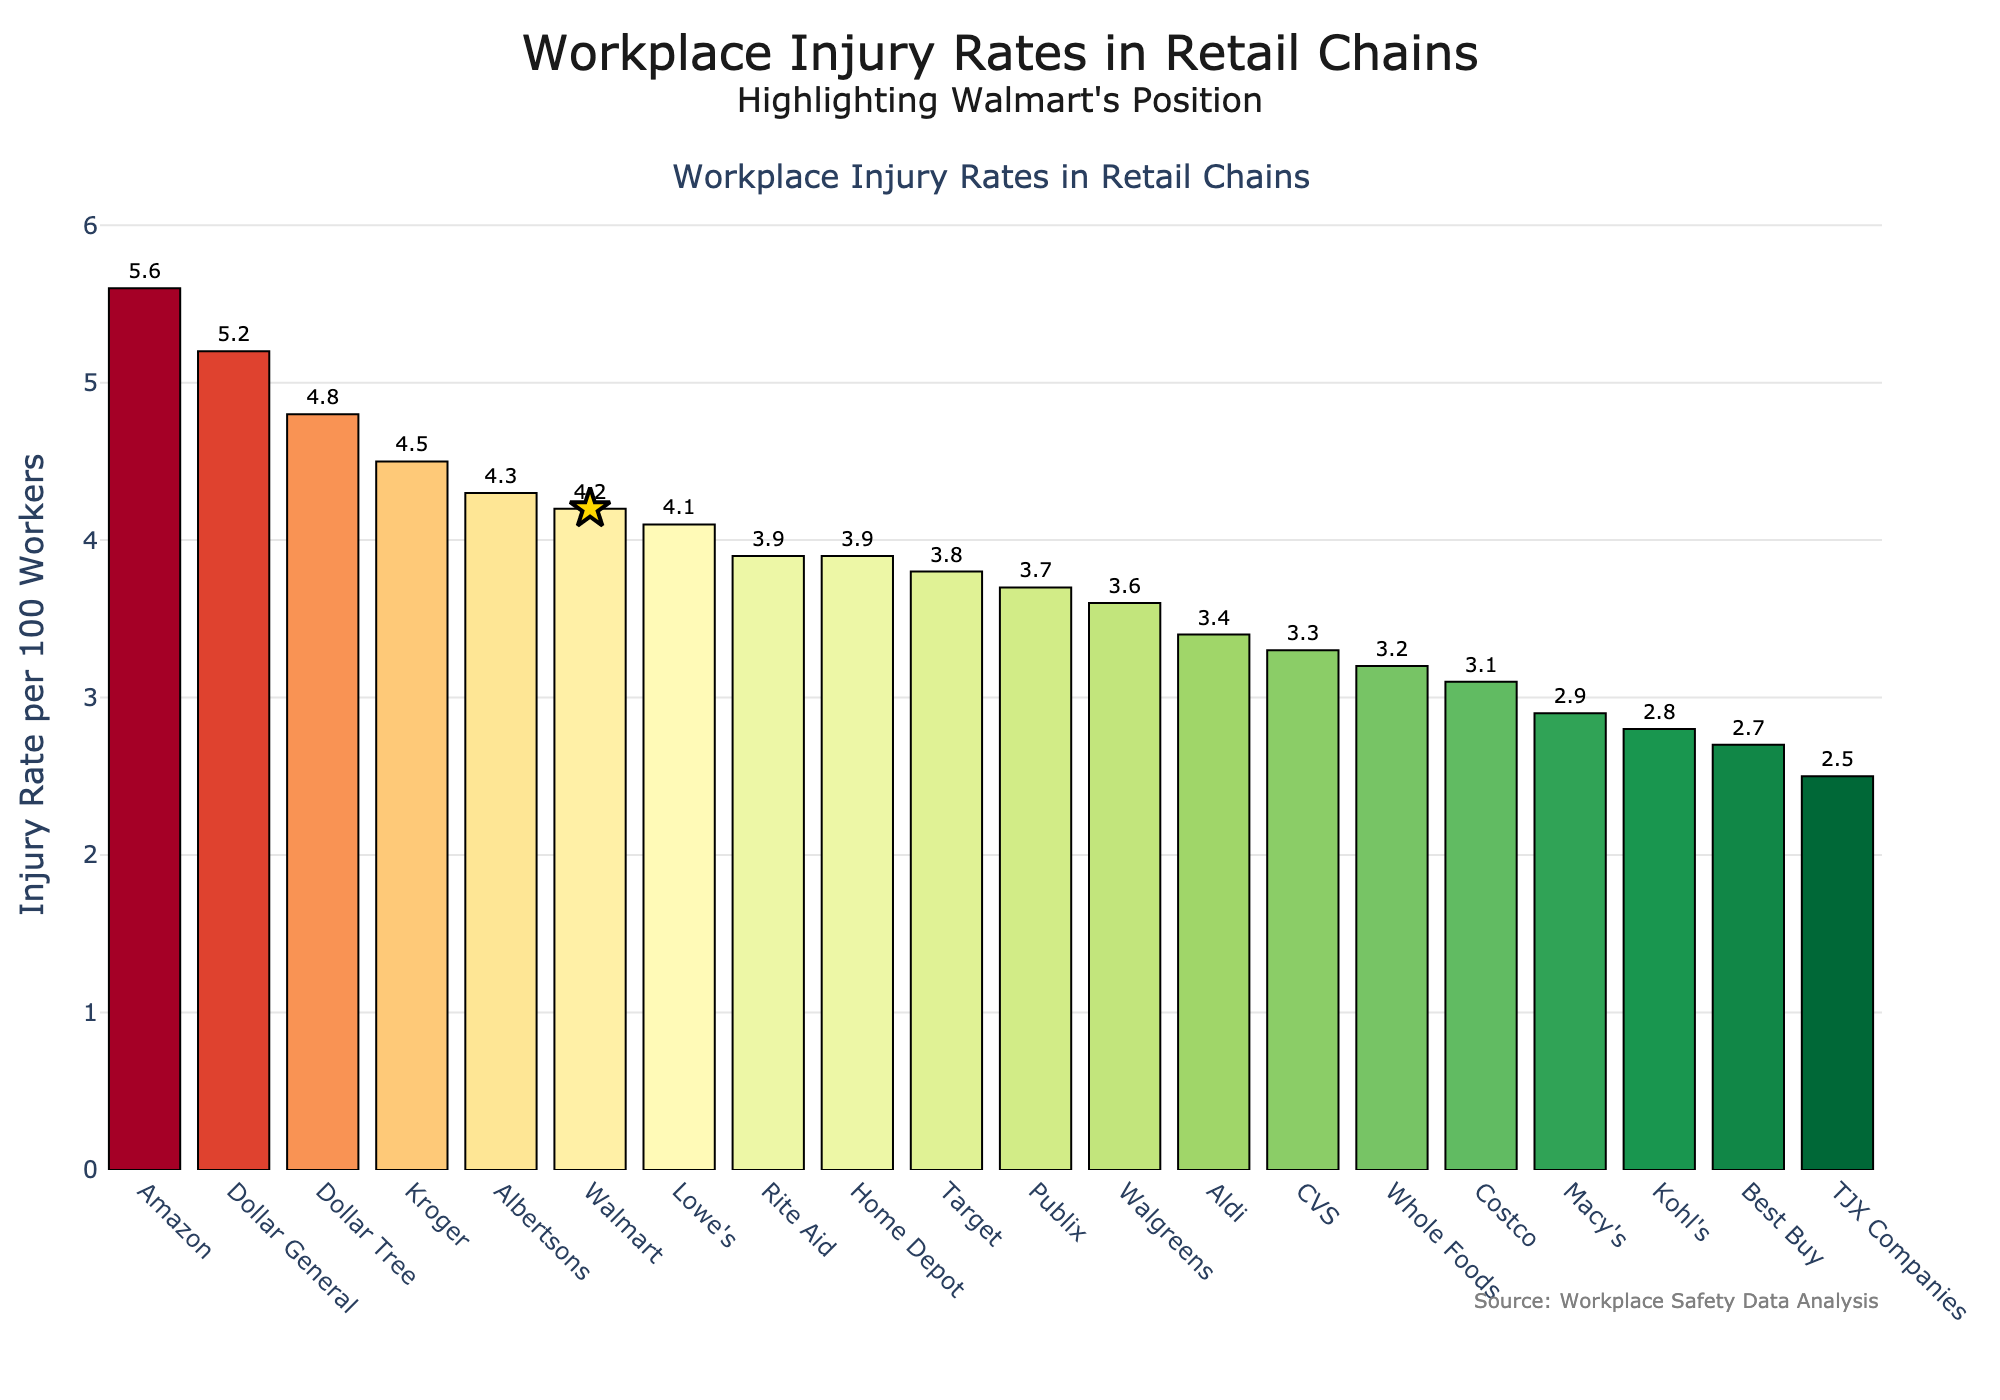Which company has the highest workplace injury rate? Observing the figure, the bar representing Amazon is the tallest, indicating that it has the highest injury rate among the companies listed.
Answer: Amazon What is Walmart's injury rate, and how does it compare to the average injury rate of all companies? Walmart's injury rate is 4.2. To find the average, we sum all injury rates and divide by the number of companies: (4.2 + 3.8 + 3.1 + 5.6 + 3.9 + 4.1 + 2.7 + 4.5 + 3.3 + 3.6 + 2.9 + 5.2 + 4.8 + 3.7 + 4.3 + 2.5 + 3.4 + 2.8 + 3.2 + 3.9) / 20 = 3.785. Walmart's rate is higher than the average.
Answer: 4.2, higher Which company has a workplace injury rate closest to Walmart but still lower? Observing the bars closely, Lowe's has a rate of 4.1, which is slightly lower than Walmart's rate of 4.2.
Answer: Lowe's Rank the top three companies with the highest injury rates. By examining the heights of the bars, the three tallest bars correspond to Amazon (5.6), Dollar General (5.2), and Dollar Tree (4.8).
Answer: Amazon, Dollar General, Dollar Tree Which company has the lowest workplace injury rate, and what is its rate? The shortest bar represents TJX Companies, which has the lowest workplace injury rate. The height of this bar indicates a rate of 2.5.
Answer: TJX Companies, 2.5 How much greater is Amazon's injury rate compared to Walmart's? Amazon's injury rate is 5.6, and Walmart's is 4.2. Subtracting the two gives 5.6 - 4.2 = 1.4. Thus, Amazon's rate is 1.4 higher than Walmart's.
Answer: 1.4 Which companies have injury rates above 4.0? By observing the bars above 4.0, we identify Amazon, Dollar General, Dollar Tree, Kroger, Albertsons, and Walmart.
Answer: Amazon, Dollar General, Dollar Tree, Kroger, Albertsons, Walmart Compare the injury rates of the highest and lowest companies. What is the difference? The highest rate is Amazon's at 5.6, and the lowest is TJX Companies at 2.5. Subtracting the two gives 5.6 - 2.5 = 3.1. The difference between the highest and lowest injury rates is 3.1.
Answer: 3.1 Can you identify the companies with injury rates between 3.0 and 4.0? By examining the bars that fall within the 3.0 to 4.0 range, the companies are Target (3.8), Home Depot (3.9), CVS (3.3), Walgreens (3.6), Publix (3.7), Aldi (3.4), Whole Foods (3.2), and Rite Aid (3.9).
Answer: Target, Home Depot, CVS, Walgreens, Publix, Aldi, Whole Foods, Rite Aid What is the combined injury rate of the companies with rates under 3.0? The companies with rates under 3.0 are Best Buy (2.7), Macy's (2.9), TJX Companies (2.5), and Kohl's (2.8). Summing these rates gives 2.7 + 2.9 + 2.5 + 2.8 = 10.9.
Answer: 10.9 